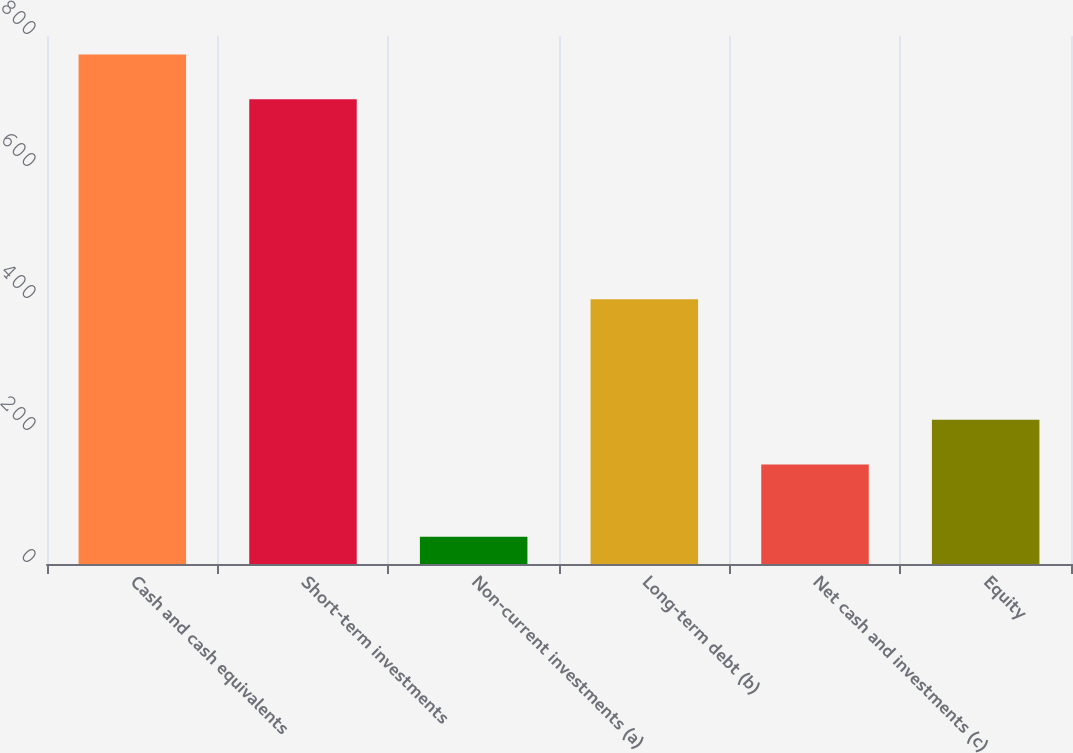<chart> <loc_0><loc_0><loc_500><loc_500><bar_chart><fcel>Cash and cash equivalents<fcel>Short-term investments<fcel>Non-current investments (a)<fcel>Long-term debt (b)<fcel>Net cash and investments (c)<fcel>Equity<nl><fcel>771.92<fcel>704<fcel>41.3<fcel>401.1<fcel>150.7<fcel>218.62<nl></chart> 